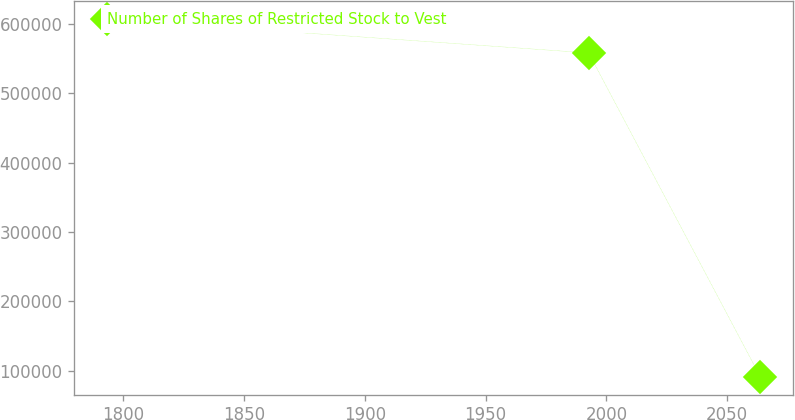Convert chart to OTSL. <chart><loc_0><loc_0><loc_500><loc_500><line_chart><ecel><fcel>Number of Shares of Restricted Stock to Vest<nl><fcel>1793.14<fcel>607106<nl><fcel>1992.65<fcel>558200<nl><fcel>2063.71<fcel>91271.5<nl></chart> 